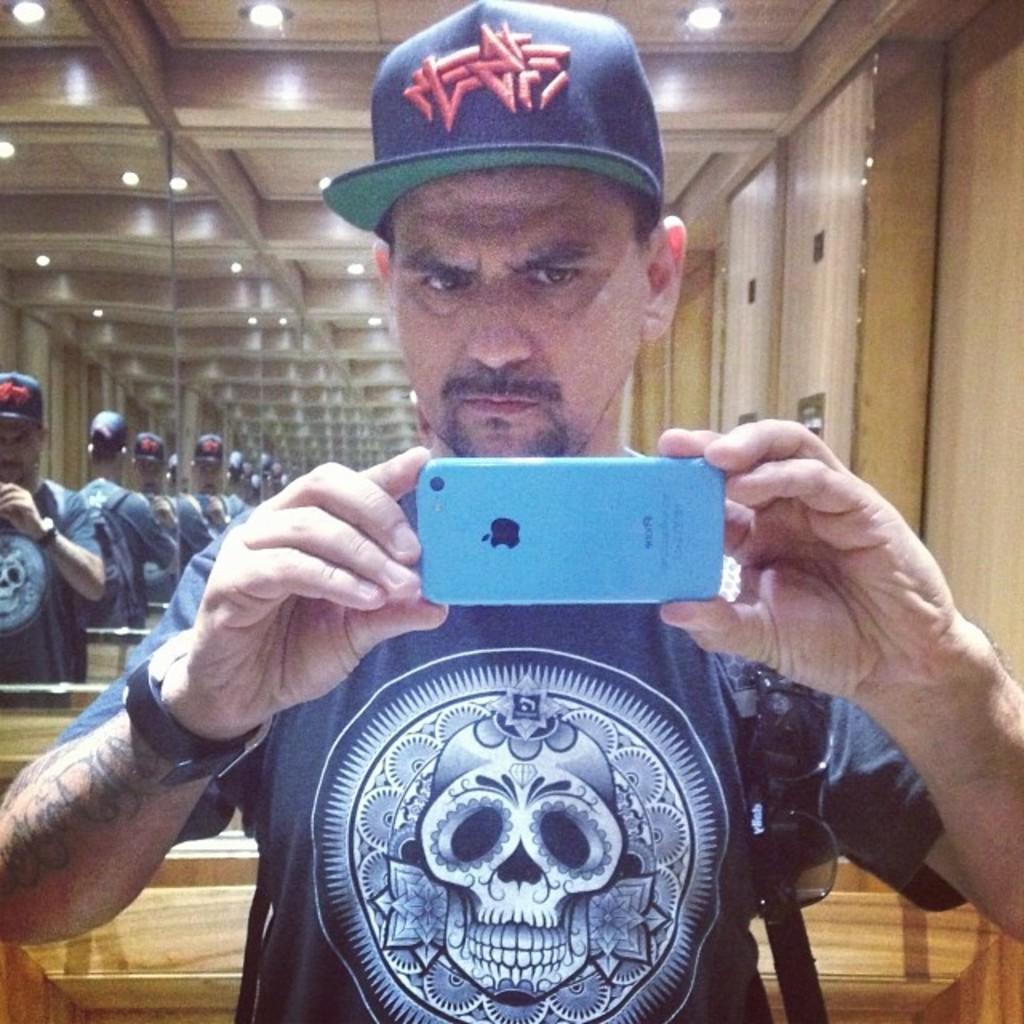Please provide a concise description of this image. In the foreground of this image, there is a man holding a camera and wearing a bag. Behind him, there are mirrors, lights at the top and the wooden wall. 